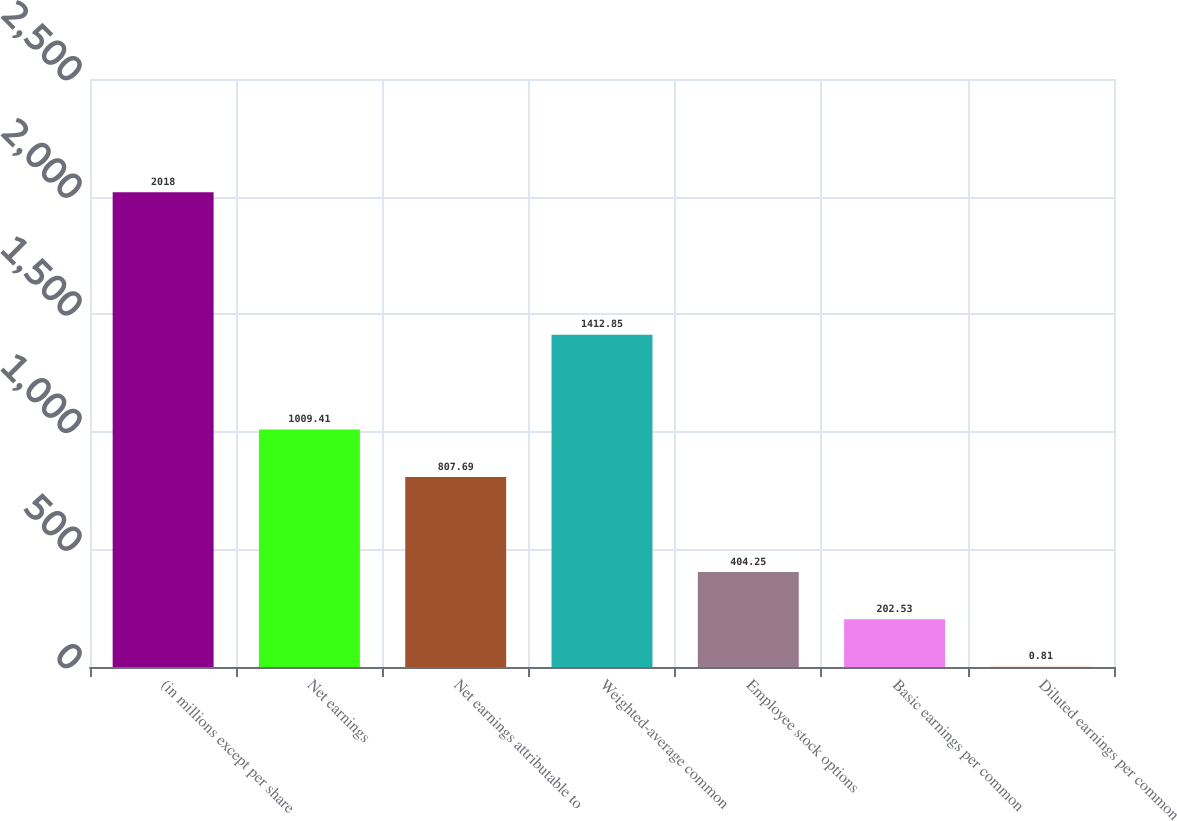Convert chart to OTSL. <chart><loc_0><loc_0><loc_500><loc_500><bar_chart><fcel>(in millions except per share<fcel>Net earnings<fcel>Net earnings attributable to<fcel>Weighted-average common<fcel>Employee stock options<fcel>Basic earnings per common<fcel>Diluted earnings per common<nl><fcel>2018<fcel>1009.41<fcel>807.69<fcel>1412.85<fcel>404.25<fcel>202.53<fcel>0.81<nl></chart> 